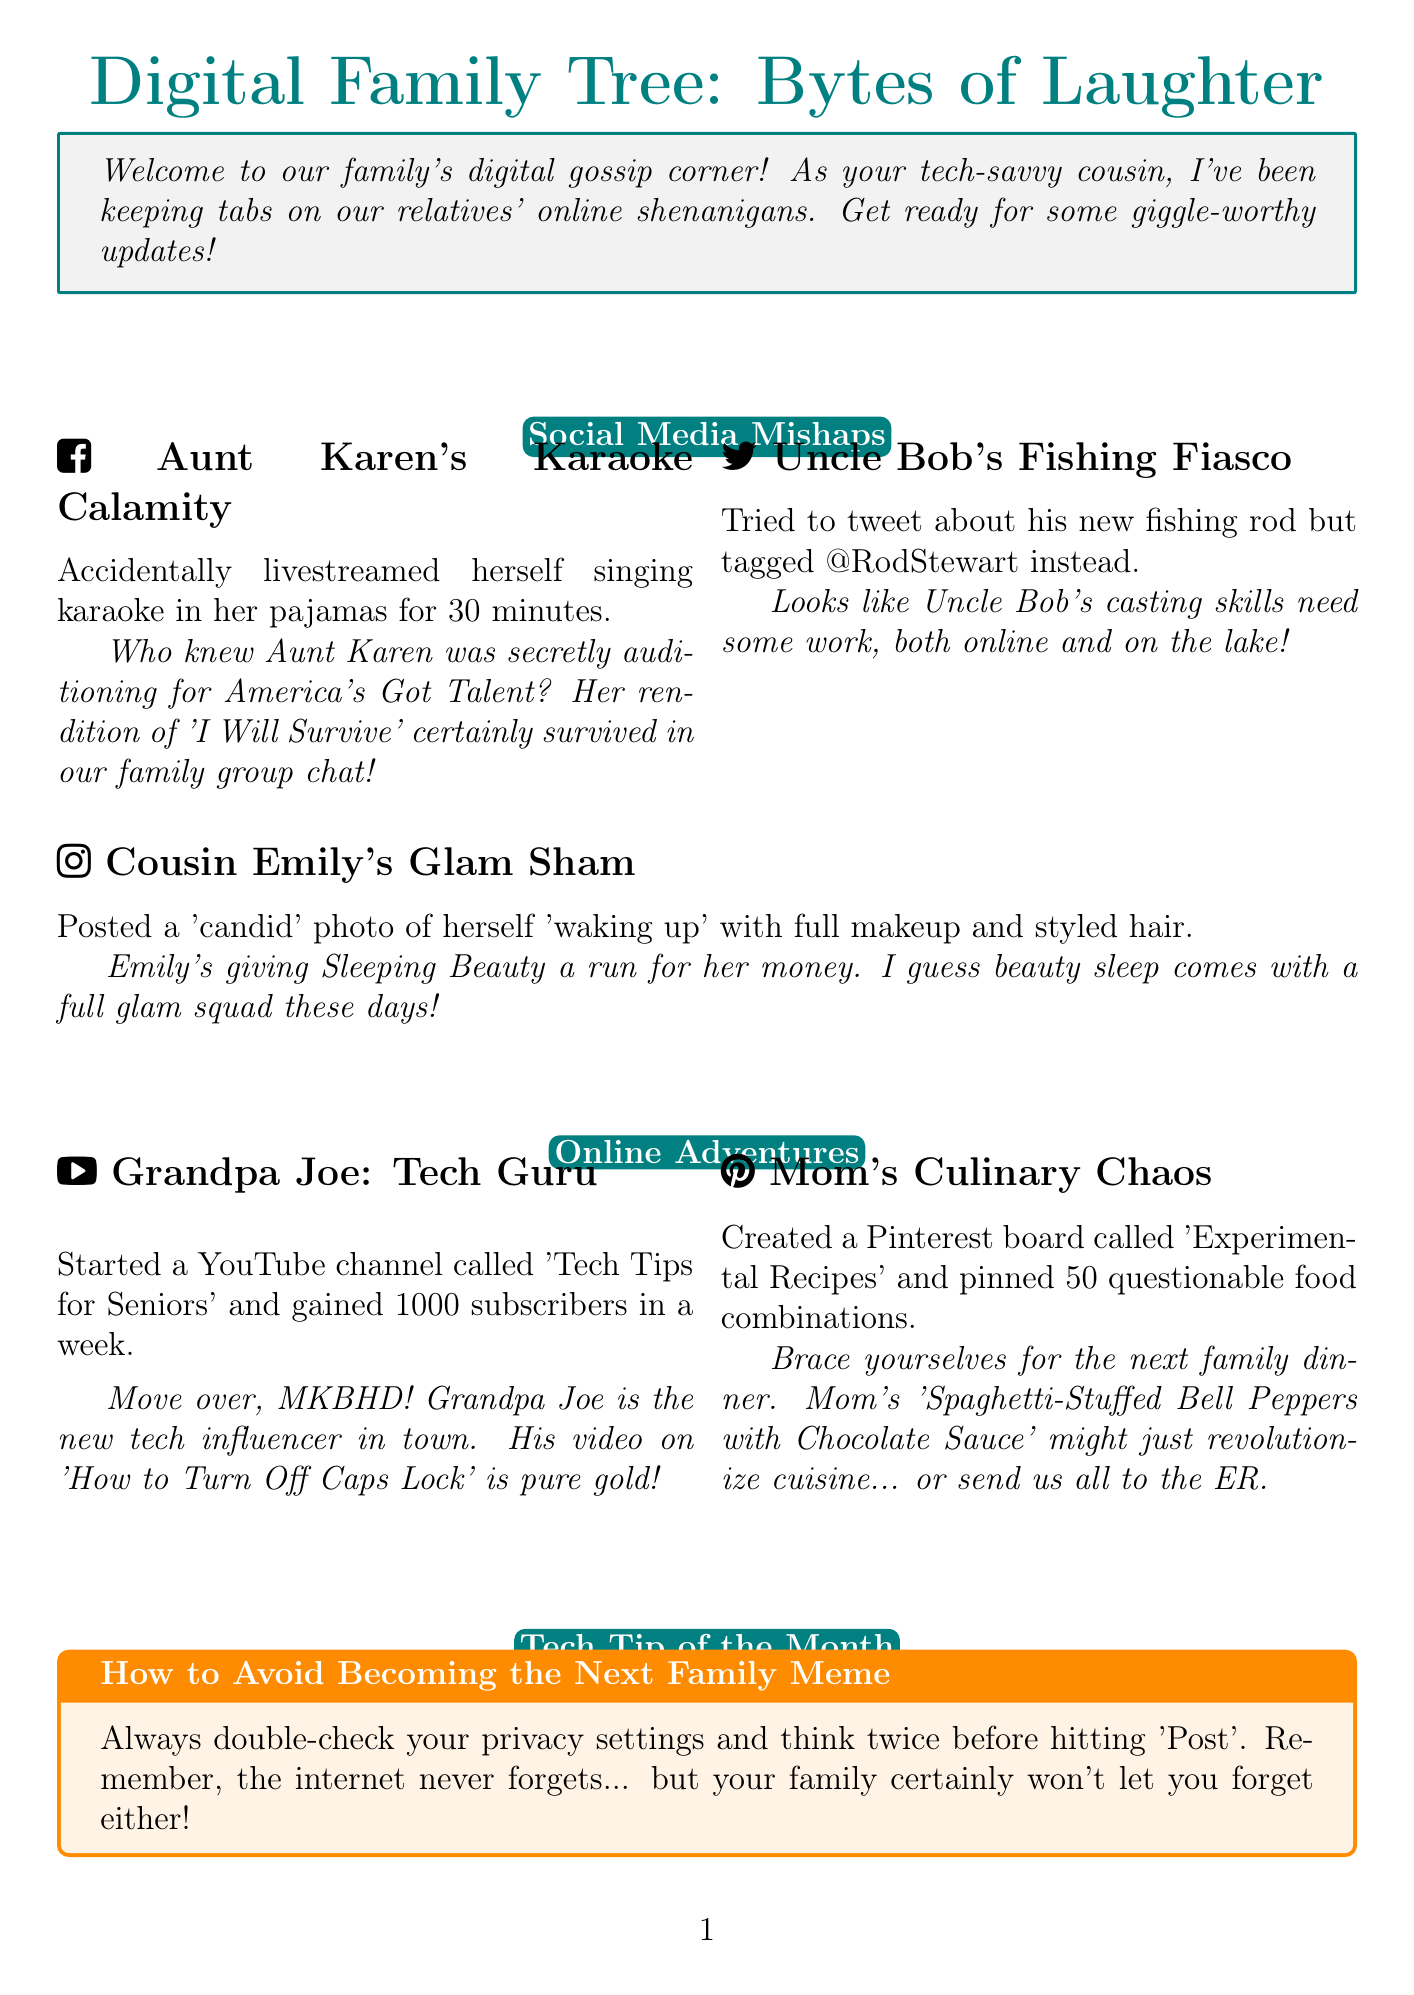What is the title of the newsletter? The title of the newsletter is clearly stated at the top of the document.
Answer: Digital Family Tree: Bytes of Laughter Who accidentally livestreamed herself singing karaoke? The document lists specific incidents involving family members, including Aunt Karen's karaoke mishap.
Answer: Aunt Karen How many subscribers did Grandpa Joe gain in a week? The document provides specific details about Grandpa Joe's YouTube channel and its subscriber count.
Answer: 1000 What is the tech tip of the month? The document presents a tech tip highlighted in a special box, summarizing the advice given.
Answer: How to Avoid Becoming the Next Family Meme What is the incident involving Uncle Bob? The newsletter describes mishaps of family members, including Uncle Bob's attempt to tweet.
Answer: Tagged @RodStewart instead Which family member posted a 'candid' photo with full makeup? The document describes a specific social media incident involving Cousin Emily.
Answer: Cousin Emily What type of board did Mom create on Pinterest? The document details Mom's online activity, specifically mentioning what her Pinterest board is about.
Answer: Experimental Recipes What commentary is given about Emily's photo? Each incident is accompanied by humorous commentary about the event.
Answer: Emily's giving Sleeping Beauty a run for her money What food combination might send the family to the ER? The document humorously suggests an unusual recipe combination created by Mom.
Answer: Spaghetti-Stuffed Bell Peppers with Chocolate Sauce 